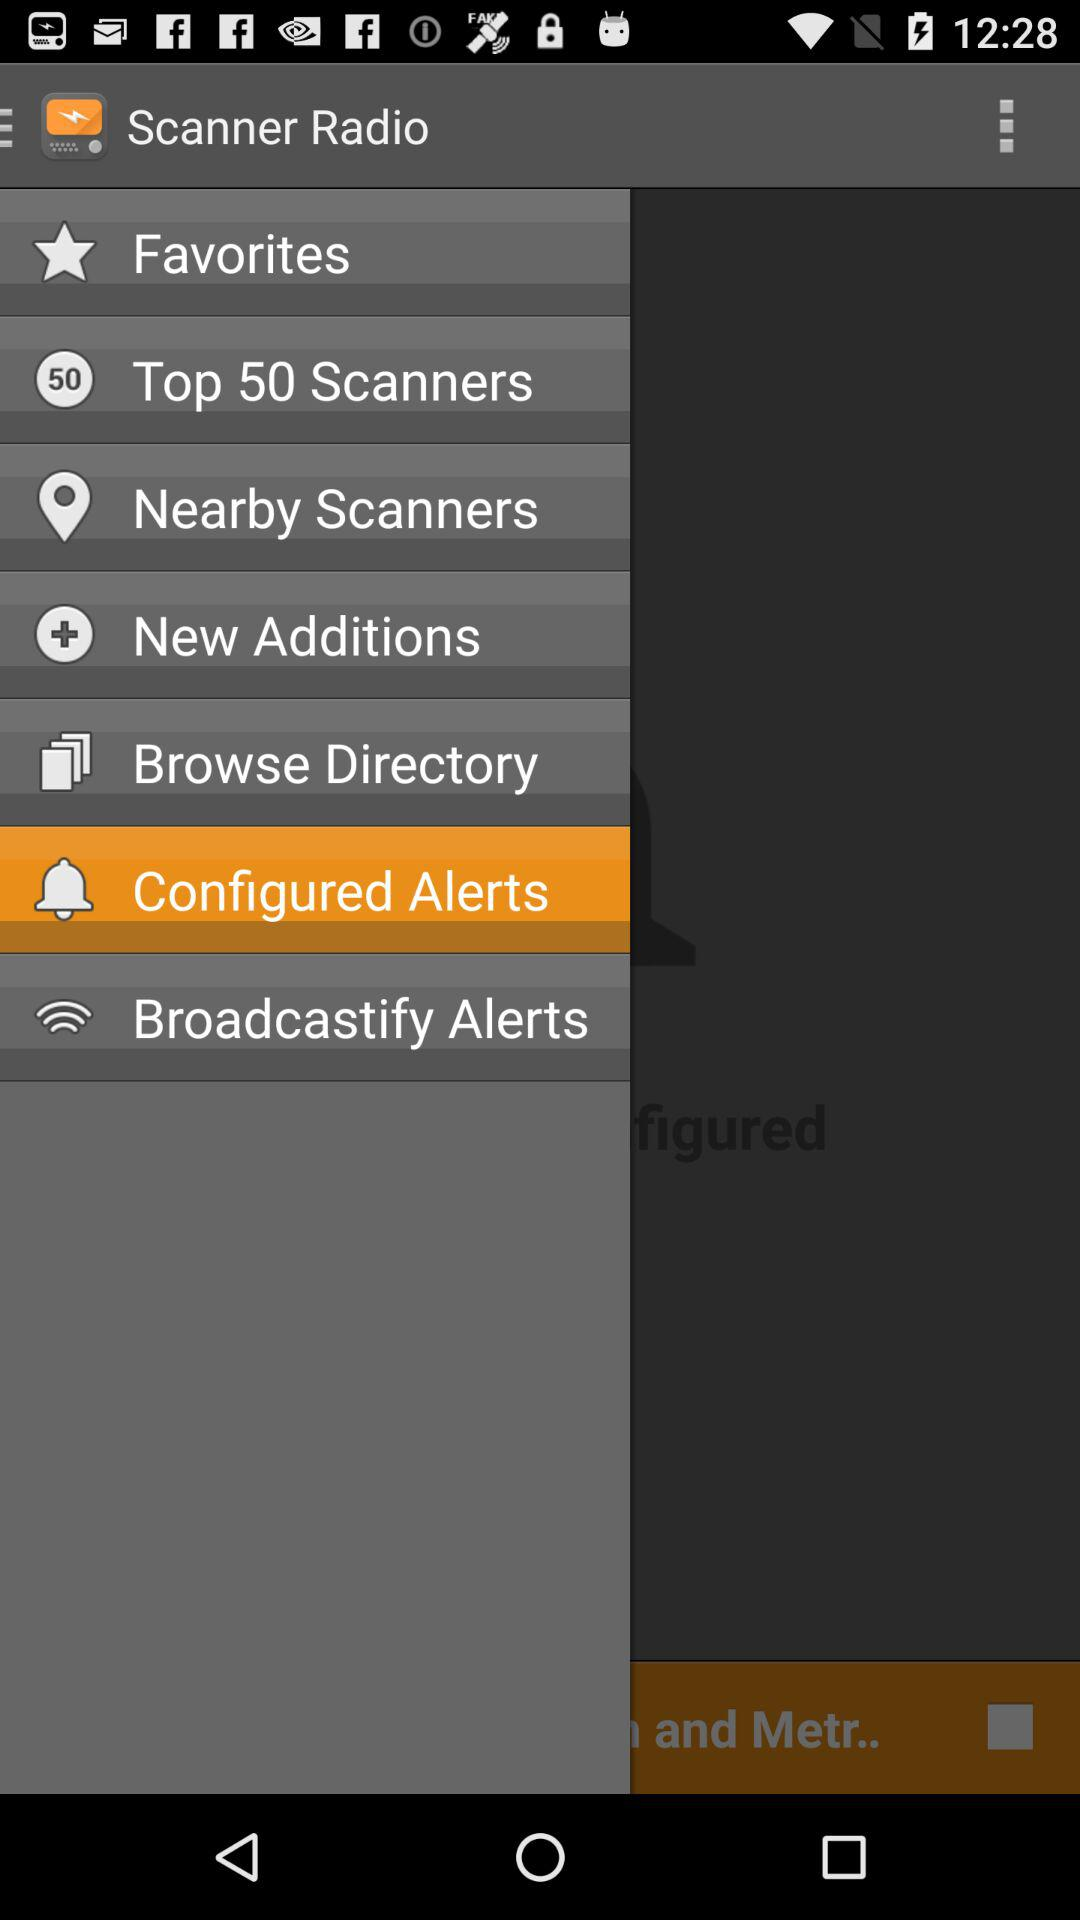What is the selected item? The selected item is "Configured Alerts". 